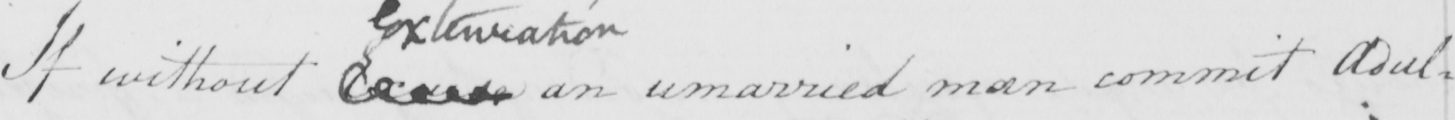Please provide the text content of this handwritten line. If without Excuse an unmarried man commit Adul= 